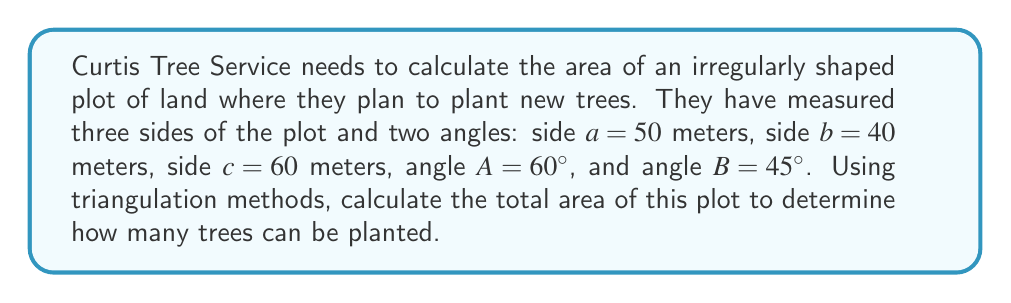Could you help me with this problem? To solve this problem, we'll use triangulation methods to divide the irregular plot into two triangles and calculate their areas separately.

Step 1: Divide the plot into two triangles.
Triangle 1: Using side a, b, and angle C (which we'll calculate)
Triangle 2: Using side b, c, and angle B (given)

Step 2: Calculate angle C
We know that the sum of angles in a triangle is 180°. So:
$C = 180° - (A + B) = 180° - (60° + 45°) = 75°$

Step 3: Calculate the area of Triangle 1 using the sine formula
Area = $\frac{1}{2}ab\sin(C)$
Area1 = $\frac{1}{2} \cdot 50 \cdot 40 \cdot \sin(75°)$
Area1 ≈ 965.93 m²

Step 4: Calculate the area of Triangle 2 using the sine formula
Area = $\frac{1}{2}bc\sin(B)$
Area2 = $\frac{1}{2} \cdot 40 \cdot 60 \cdot \sin(45°)$
Area2 ≈ 848.53 m²

Step 5: Calculate the total area by adding the areas of both triangles
Total Area = Area1 + Area2
Total Area ≈ 965.93 + 848.53 = 1814.46 m²

[asy]
import geometry;

size(200);

pair A = (0,0);
pair B = (50,0);
pair C = (40*cos(60*pi/180), 40*sin(60*pi/180));

draw(A--B--C--cycle);

label("A", A, SW);
label("B", B, SE);
label("C", C, N);

label("50m", (A+B)/2, S);
label("40m", (B+C)/2, NE);
label("60m", (A+C)/2, NW);

draw(arc(A, 10, 0, 60), Arrow);
label("60°", A+(7,7), NE);

draw(arc(B, 10, 180-45, 180), Arrow);
label("45°", B+(-7,7), NW);

draw(arc(C, 10, -75, 0), Arrow);
label("75°", C+(7,-7), SE);
[/asy]
Answer: 1814.46 m² 